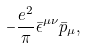<formula> <loc_0><loc_0><loc_500><loc_500>- \frac { e ^ { 2 } } { \pi } \bar { \epsilon } ^ { \mu \nu } \bar { p } _ { \mu } ,</formula> 